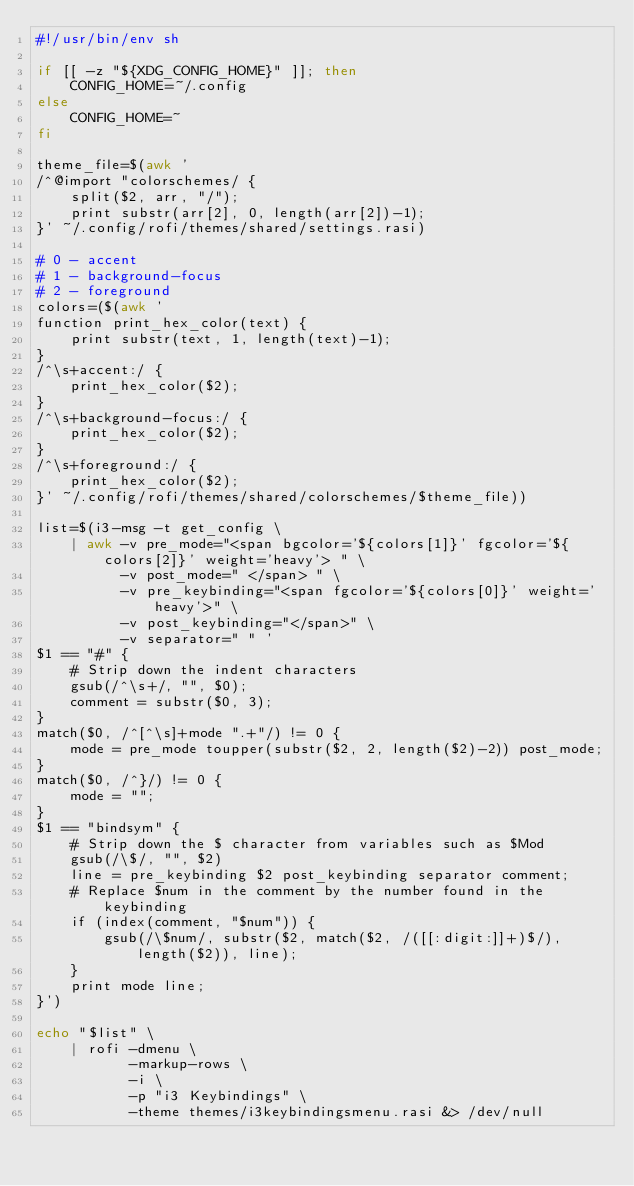Convert code to text. <code><loc_0><loc_0><loc_500><loc_500><_Bash_>#!/usr/bin/env sh

if [[ -z "${XDG_CONFIG_HOME}" ]]; then
	CONFIG_HOME=~/.config
else
    CONFIG_HOME=~
fi

theme_file=$(awk '
/^@import "colorschemes/ {
    split($2, arr, "/");
    print substr(arr[2], 0, length(arr[2])-1);
}' ~/.config/rofi/themes/shared/settings.rasi)

# 0 - accent
# 1 - background-focus
# 2 - foreground
colors=($(awk '
function print_hex_color(text) {
    print substr(text, 1, length(text)-1);
}
/^\s+accent:/ {
    print_hex_color($2);
}
/^\s+background-focus:/ {
    print_hex_color($2);
}
/^\s+foreground:/ {
    print_hex_color($2);
}' ~/.config/rofi/themes/shared/colorschemes/$theme_file))

list=$(i3-msg -t get_config \
    | awk -v pre_mode="<span bgcolor='${colors[1]}' fgcolor='${colors[2]}' weight='heavy'> " \
          -v post_mode=" </span> " \
          -v pre_keybinding="<span fgcolor='${colors[0]}' weight='heavy'>" \
          -v post_keybinding="</span>" \
          -v separator=" " '
$1 == "#" {
    # Strip down the indent characters
    gsub(/^\s+/, "", $0);
    comment = substr($0, 3);
}
match($0, /^[^\s]+mode ".+"/) != 0 {
    mode = pre_mode toupper(substr($2, 2, length($2)-2)) post_mode;
}
match($0, /^}/) != 0 {
    mode = "";
}
$1 == "bindsym" {
    # Strip down the $ character from variables such as $Mod
    gsub(/\$/, "", $2)
    line = pre_keybinding $2 post_keybinding separator comment;
    # Replace $num in the comment by the number found in the keybinding
    if (index(comment, "$num")) {
        gsub(/\$num/, substr($2, match($2, /([[:digit:]]+)$/), length($2)), line);
    }
    print mode line;
}')

echo "$list" \
    | rofi -dmenu \
           -markup-rows \
           -i \
           -p "i3 Keybindings" \
           -theme themes/i3keybindingsmenu.rasi &> /dev/null
</code> 